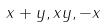<formula> <loc_0><loc_0><loc_500><loc_500>x + y , x y , - x</formula> 